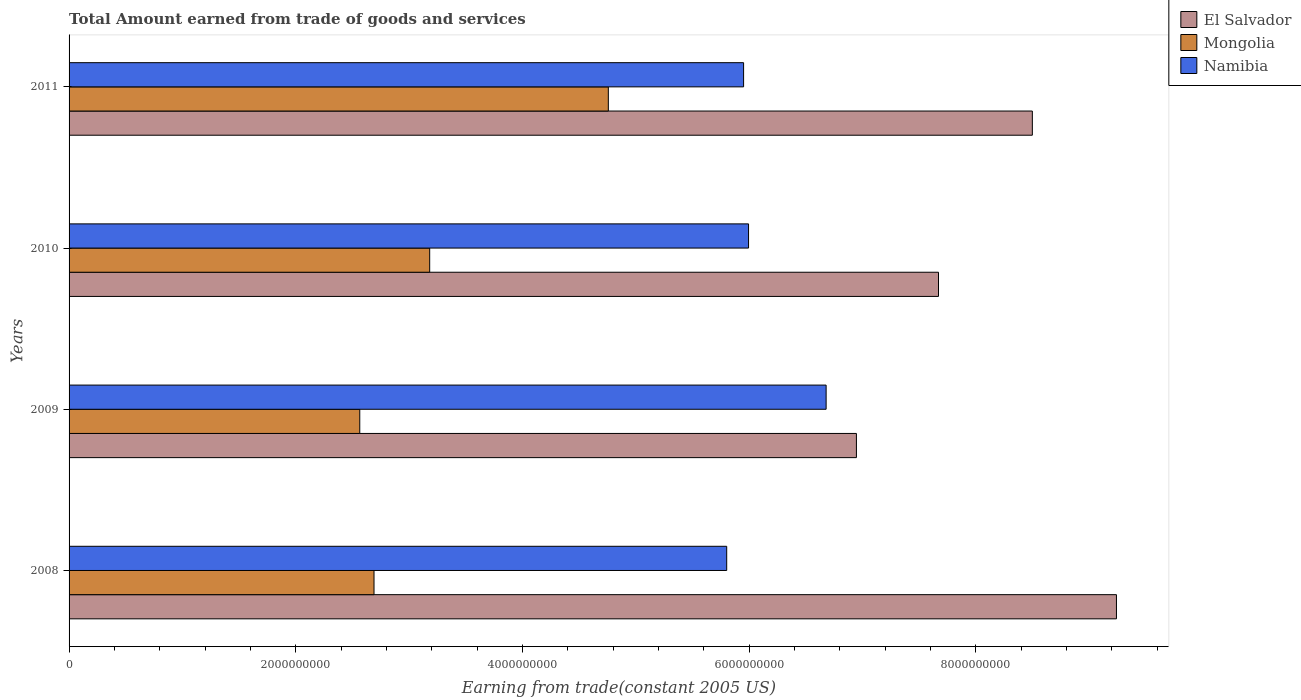How many groups of bars are there?
Your response must be concise. 4. How many bars are there on the 4th tick from the top?
Your answer should be compact. 3. What is the label of the 3rd group of bars from the top?
Keep it short and to the point. 2009. What is the total amount earned by trading goods and services in Namibia in 2008?
Make the answer very short. 5.80e+09. Across all years, what is the maximum total amount earned by trading goods and services in Mongolia?
Your response must be concise. 4.76e+09. Across all years, what is the minimum total amount earned by trading goods and services in Namibia?
Your answer should be compact. 5.80e+09. In which year was the total amount earned by trading goods and services in El Salvador maximum?
Offer a very short reply. 2008. What is the total total amount earned by trading goods and services in Namibia in the graph?
Ensure brevity in your answer.  2.44e+1. What is the difference between the total amount earned by trading goods and services in Namibia in 2010 and that in 2011?
Ensure brevity in your answer.  4.37e+07. What is the difference between the total amount earned by trading goods and services in Namibia in 2009 and the total amount earned by trading goods and services in El Salvador in 2011?
Your answer should be very brief. -1.82e+09. What is the average total amount earned by trading goods and services in Mongolia per year?
Offer a terse response. 3.30e+09. In the year 2011, what is the difference between the total amount earned by trading goods and services in Mongolia and total amount earned by trading goods and services in El Salvador?
Provide a succinct answer. -3.74e+09. What is the ratio of the total amount earned by trading goods and services in Mongolia in 2009 to that in 2010?
Provide a short and direct response. 0.81. Is the total amount earned by trading goods and services in El Salvador in 2009 less than that in 2011?
Ensure brevity in your answer.  Yes. Is the difference between the total amount earned by trading goods and services in Mongolia in 2008 and 2010 greater than the difference between the total amount earned by trading goods and services in El Salvador in 2008 and 2010?
Provide a succinct answer. No. What is the difference between the highest and the second highest total amount earned by trading goods and services in Namibia?
Offer a terse response. 6.84e+08. What is the difference between the highest and the lowest total amount earned by trading goods and services in Namibia?
Your answer should be very brief. 8.77e+08. In how many years, is the total amount earned by trading goods and services in Mongolia greater than the average total amount earned by trading goods and services in Mongolia taken over all years?
Your response must be concise. 1. What does the 1st bar from the top in 2011 represents?
Provide a succinct answer. Namibia. What does the 1st bar from the bottom in 2008 represents?
Your answer should be compact. El Salvador. Is it the case that in every year, the sum of the total amount earned by trading goods and services in El Salvador and total amount earned by trading goods and services in Mongolia is greater than the total amount earned by trading goods and services in Namibia?
Your response must be concise. Yes. How many bars are there?
Provide a short and direct response. 12. Are all the bars in the graph horizontal?
Your response must be concise. Yes. What is the difference between two consecutive major ticks on the X-axis?
Ensure brevity in your answer.  2.00e+09. Does the graph contain any zero values?
Ensure brevity in your answer.  No. Does the graph contain grids?
Offer a very short reply. No. How many legend labels are there?
Provide a short and direct response. 3. How are the legend labels stacked?
Keep it short and to the point. Vertical. What is the title of the graph?
Your answer should be very brief. Total Amount earned from trade of goods and services. Does "Latvia" appear as one of the legend labels in the graph?
Make the answer very short. No. What is the label or title of the X-axis?
Offer a very short reply. Earning from trade(constant 2005 US). What is the Earning from trade(constant 2005 US) in El Salvador in 2008?
Provide a short and direct response. 9.24e+09. What is the Earning from trade(constant 2005 US) in Mongolia in 2008?
Your answer should be very brief. 2.69e+09. What is the Earning from trade(constant 2005 US) in Namibia in 2008?
Offer a very short reply. 5.80e+09. What is the Earning from trade(constant 2005 US) in El Salvador in 2009?
Provide a succinct answer. 6.95e+09. What is the Earning from trade(constant 2005 US) in Mongolia in 2009?
Ensure brevity in your answer.  2.56e+09. What is the Earning from trade(constant 2005 US) of Namibia in 2009?
Offer a very short reply. 6.68e+09. What is the Earning from trade(constant 2005 US) of El Salvador in 2010?
Give a very brief answer. 7.67e+09. What is the Earning from trade(constant 2005 US) in Mongolia in 2010?
Give a very brief answer. 3.18e+09. What is the Earning from trade(constant 2005 US) of Namibia in 2010?
Your response must be concise. 5.99e+09. What is the Earning from trade(constant 2005 US) in El Salvador in 2011?
Keep it short and to the point. 8.50e+09. What is the Earning from trade(constant 2005 US) in Mongolia in 2011?
Ensure brevity in your answer.  4.76e+09. What is the Earning from trade(constant 2005 US) of Namibia in 2011?
Offer a terse response. 5.95e+09. Across all years, what is the maximum Earning from trade(constant 2005 US) in El Salvador?
Give a very brief answer. 9.24e+09. Across all years, what is the maximum Earning from trade(constant 2005 US) of Mongolia?
Provide a short and direct response. 4.76e+09. Across all years, what is the maximum Earning from trade(constant 2005 US) in Namibia?
Keep it short and to the point. 6.68e+09. Across all years, what is the minimum Earning from trade(constant 2005 US) of El Salvador?
Make the answer very short. 6.95e+09. Across all years, what is the minimum Earning from trade(constant 2005 US) in Mongolia?
Give a very brief answer. 2.56e+09. Across all years, what is the minimum Earning from trade(constant 2005 US) of Namibia?
Your answer should be very brief. 5.80e+09. What is the total Earning from trade(constant 2005 US) of El Salvador in the graph?
Provide a short and direct response. 3.24e+1. What is the total Earning from trade(constant 2005 US) of Mongolia in the graph?
Your answer should be compact. 1.32e+1. What is the total Earning from trade(constant 2005 US) of Namibia in the graph?
Your answer should be very brief. 2.44e+1. What is the difference between the Earning from trade(constant 2005 US) in El Salvador in 2008 and that in 2009?
Keep it short and to the point. 2.29e+09. What is the difference between the Earning from trade(constant 2005 US) in Mongolia in 2008 and that in 2009?
Keep it short and to the point. 1.26e+08. What is the difference between the Earning from trade(constant 2005 US) in Namibia in 2008 and that in 2009?
Offer a terse response. -8.77e+08. What is the difference between the Earning from trade(constant 2005 US) of El Salvador in 2008 and that in 2010?
Offer a very short reply. 1.57e+09. What is the difference between the Earning from trade(constant 2005 US) of Mongolia in 2008 and that in 2010?
Make the answer very short. -4.91e+08. What is the difference between the Earning from trade(constant 2005 US) in Namibia in 2008 and that in 2010?
Provide a succinct answer. -1.93e+08. What is the difference between the Earning from trade(constant 2005 US) in El Salvador in 2008 and that in 2011?
Provide a succinct answer. 7.42e+08. What is the difference between the Earning from trade(constant 2005 US) of Mongolia in 2008 and that in 2011?
Offer a terse response. -2.07e+09. What is the difference between the Earning from trade(constant 2005 US) in Namibia in 2008 and that in 2011?
Give a very brief answer. -1.49e+08. What is the difference between the Earning from trade(constant 2005 US) in El Salvador in 2009 and that in 2010?
Your response must be concise. -7.24e+08. What is the difference between the Earning from trade(constant 2005 US) in Mongolia in 2009 and that in 2010?
Your answer should be very brief. -6.17e+08. What is the difference between the Earning from trade(constant 2005 US) in Namibia in 2009 and that in 2010?
Provide a succinct answer. 6.84e+08. What is the difference between the Earning from trade(constant 2005 US) of El Salvador in 2009 and that in 2011?
Make the answer very short. -1.55e+09. What is the difference between the Earning from trade(constant 2005 US) in Mongolia in 2009 and that in 2011?
Give a very brief answer. -2.19e+09. What is the difference between the Earning from trade(constant 2005 US) of Namibia in 2009 and that in 2011?
Provide a succinct answer. 7.28e+08. What is the difference between the Earning from trade(constant 2005 US) of El Salvador in 2010 and that in 2011?
Make the answer very short. -8.28e+08. What is the difference between the Earning from trade(constant 2005 US) in Mongolia in 2010 and that in 2011?
Your answer should be very brief. -1.58e+09. What is the difference between the Earning from trade(constant 2005 US) of Namibia in 2010 and that in 2011?
Provide a succinct answer. 4.37e+07. What is the difference between the Earning from trade(constant 2005 US) of El Salvador in 2008 and the Earning from trade(constant 2005 US) of Mongolia in 2009?
Keep it short and to the point. 6.68e+09. What is the difference between the Earning from trade(constant 2005 US) in El Salvador in 2008 and the Earning from trade(constant 2005 US) in Namibia in 2009?
Your answer should be very brief. 2.56e+09. What is the difference between the Earning from trade(constant 2005 US) in Mongolia in 2008 and the Earning from trade(constant 2005 US) in Namibia in 2009?
Make the answer very short. -3.99e+09. What is the difference between the Earning from trade(constant 2005 US) of El Salvador in 2008 and the Earning from trade(constant 2005 US) of Mongolia in 2010?
Keep it short and to the point. 6.06e+09. What is the difference between the Earning from trade(constant 2005 US) in El Salvador in 2008 and the Earning from trade(constant 2005 US) in Namibia in 2010?
Keep it short and to the point. 3.25e+09. What is the difference between the Earning from trade(constant 2005 US) of Mongolia in 2008 and the Earning from trade(constant 2005 US) of Namibia in 2010?
Offer a terse response. -3.30e+09. What is the difference between the Earning from trade(constant 2005 US) of El Salvador in 2008 and the Earning from trade(constant 2005 US) of Mongolia in 2011?
Keep it short and to the point. 4.48e+09. What is the difference between the Earning from trade(constant 2005 US) in El Salvador in 2008 and the Earning from trade(constant 2005 US) in Namibia in 2011?
Keep it short and to the point. 3.29e+09. What is the difference between the Earning from trade(constant 2005 US) of Mongolia in 2008 and the Earning from trade(constant 2005 US) of Namibia in 2011?
Your answer should be very brief. -3.26e+09. What is the difference between the Earning from trade(constant 2005 US) in El Salvador in 2009 and the Earning from trade(constant 2005 US) in Mongolia in 2010?
Offer a terse response. 3.76e+09. What is the difference between the Earning from trade(constant 2005 US) of El Salvador in 2009 and the Earning from trade(constant 2005 US) of Namibia in 2010?
Provide a succinct answer. 9.52e+08. What is the difference between the Earning from trade(constant 2005 US) of Mongolia in 2009 and the Earning from trade(constant 2005 US) of Namibia in 2010?
Your answer should be compact. -3.43e+09. What is the difference between the Earning from trade(constant 2005 US) in El Salvador in 2009 and the Earning from trade(constant 2005 US) in Mongolia in 2011?
Your answer should be very brief. 2.19e+09. What is the difference between the Earning from trade(constant 2005 US) of El Salvador in 2009 and the Earning from trade(constant 2005 US) of Namibia in 2011?
Your answer should be compact. 9.95e+08. What is the difference between the Earning from trade(constant 2005 US) in Mongolia in 2009 and the Earning from trade(constant 2005 US) in Namibia in 2011?
Your response must be concise. -3.39e+09. What is the difference between the Earning from trade(constant 2005 US) in El Salvador in 2010 and the Earning from trade(constant 2005 US) in Mongolia in 2011?
Your answer should be very brief. 2.91e+09. What is the difference between the Earning from trade(constant 2005 US) in El Salvador in 2010 and the Earning from trade(constant 2005 US) in Namibia in 2011?
Offer a terse response. 1.72e+09. What is the difference between the Earning from trade(constant 2005 US) of Mongolia in 2010 and the Earning from trade(constant 2005 US) of Namibia in 2011?
Your answer should be compact. -2.77e+09. What is the average Earning from trade(constant 2005 US) of El Salvador per year?
Your answer should be very brief. 8.09e+09. What is the average Earning from trade(constant 2005 US) of Mongolia per year?
Your answer should be compact. 3.30e+09. What is the average Earning from trade(constant 2005 US) in Namibia per year?
Your response must be concise. 6.11e+09. In the year 2008, what is the difference between the Earning from trade(constant 2005 US) in El Salvador and Earning from trade(constant 2005 US) in Mongolia?
Your response must be concise. 6.55e+09. In the year 2008, what is the difference between the Earning from trade(constant 2005 US) of El Salvador and Earning from trade(constant 2005 US) of Namibia?
Provide a short and direct response. 3.44e+09. In the year 2008, what is the difference between the Earning from trade(constant 2005 US) of Mongolia and Earning from trade(constant 2005 US) of Namibia?
Make the answer very short. -3.11e+09. In the year 2009, what is the difference between the Earning from trade(constant 2005 US) in El Salvador and Earning from trade(constant 2005 US) in Mongolia?
Give a very brief answer. 4.38e+09. In the year 2009, what is the difference between the Earning from trade(constant 2005 US) of El Salvador and Earning from trade(constant 2005 US) of Namibia?
Offer a very short reply. 2.67e+08. In the year 2009, what is the difference between the Earning from trade(constant 2005 US) in Mongolia and Earning from trade(constant 2005 US) in Namibia?
Your response must be concise. -4.11e+09. In the year 2010, what is the difference between the Earning from trade(constant 2005 US) of El Salvador and Earning from trade(constant 2005 US) of Mongolia?
Make the answer very short. 4.49e+09. In the year 2010, what is the difference between the Earning from trade(constant 2005 US) in El Salvador and Earning from trade(constant 2005 US) in Namibia?
Make the answer very short. 1.68e+09. In the year 2010, what is the difference between the Earning from trade(constant 2005 US) of Mongolia and Earning from trade(constant 2005 US) of Namibia?
Offer a terse response. -2.81e+09. In the year 2011, what is the difference between the Earning from trade(constant 2005 US) in El Salvador and Earning from trade(constant 2005 US) in Mongolia?
Provide a short and direct response. 3.74e+09. In the year 2011, what is the difference between the Earning from trade(constant 2005 US) of El Salvador and Earning from trade(constant 2005 US) of Namibia?
Ensure brevity in your answer.  2.55e+09. In the year 2011, what is the difference between the Earning from trade(constant 2005 US) in Mongolia and Earning from trade(constant 2005 US) in Namibia?
Give a very brief answer. -1.19e+09. What is the ratio of the Earning from trade(constant 2005 US) of El Salvador in 2008 to that in 2009?
Provide a succinct answer. 1.33. What is the ratio of the Earning from trade(constant 2005 US) in Mongolia in 2008 to that in 2009?
Offer a terse response. 1.05. What is the ratio of the Earning from trade(constant 2005 US) of Namibia in 2008 to that in 2009?
Ensure brevity in your answer.  0.87. What is the ratio of the Earning from trade(constant 2005 US) of El Salvador in 2008 to that in 2010?
Provide a short and direct response. 1.2. What is the ratio of the Earning from trade(constant 2005 US) of Mongolia in 2008 to that in 2010?
Offer a very short reply. 0.85. What is the ratio of the Earning from trade(constant 2005 US) of Namibia in 2008 to that in 2010?
Your response must be concise. 0.97. What is the ratio of the Earning from trade(constant 2005 US) in El Salvador in 2008 to that in 2011?
Provide a succinct answer. 1.09. What is the ratio of the Earning from trade(constant 2005 US) of Mongolia in 2008 to that in 2011?
Make the answer very short. 0.57. What is the ratio of the Earning from trade(constant 2005 US) of Namibia in 2008 to that in 2011?
Your answer should be very brief. 0.97. What is the ratio of the Earning from trade(constant 2005 US) of El Salvador in 2009 to that in 2010?
Give a very brief answer. 0.91. What is the ratio of the Earning from trade(constant 2005 US) in Mongolia in 2009 to that in 2010?
Ensure brevity in your answer.  0.81. What is the ratio of the Earning from trade(constant 2005 US) in Namibia in 2009 to that in 2010?
Your answer should be compact. 1.11. What is the ratio of the Earning from trade(constant 2005 US) of El Salvador in 2009 to that in 2011?
Ensure brevity in your answer.  0.82. What is the ratio of the Earning from trade(constant 2005 US) of Mongolia in 2009 to that in 2011?
Your answer should be very brief. 0.54. What is the ratio of the Earning from trade(constant 2005 US) in Namibia in 2009 to that in 2011?
Keep it short and to the point. 1.12. What is the ratio of the Earning from trade(constant 2005 US) of El Salvador in 2010 to that in 2011?
Give a very brief answer. 0.9. What is the ratio of the Earning from trade(constant 2005 US) in Mongolia in 2010 to that in 2011?
Your answer should be very brief. 0.67. What is the ratio of the Earning from trade(constant 2005 US) of Namibia in 2010 to that in 2011?
Give a very brief answer. 1.01. What is the difference between the highest and the second highest Earning from trade(constant 2005 US) of El Salvador?
Offer a very short reply. 7.42e+08. What is the difference between the highest and the second highest Earning from trade(constant 2005 US) of Mongolia?
Give a very brief answer. 1.58e+09. What is the difference between the highest and the second highest Earning from trade(constant 2005 US) of Namibia?
Offer a terse response. 6.84e+08. What is the difference between the highest and the lowest Earning from trade(constant 2005 US) in El Salvador?
Provide a short and direct response. 2.29e+09. What is the difference between the highest and the lowest Earning from trade(constant 2005 US) in Mongolia?
Ensure brevity in your answer.  2.19e+09. What is the difference between the highest and the lowest Earning from trade(constant 2005 US) in Namibia?
Offer a terse response. 8.77e+08. 